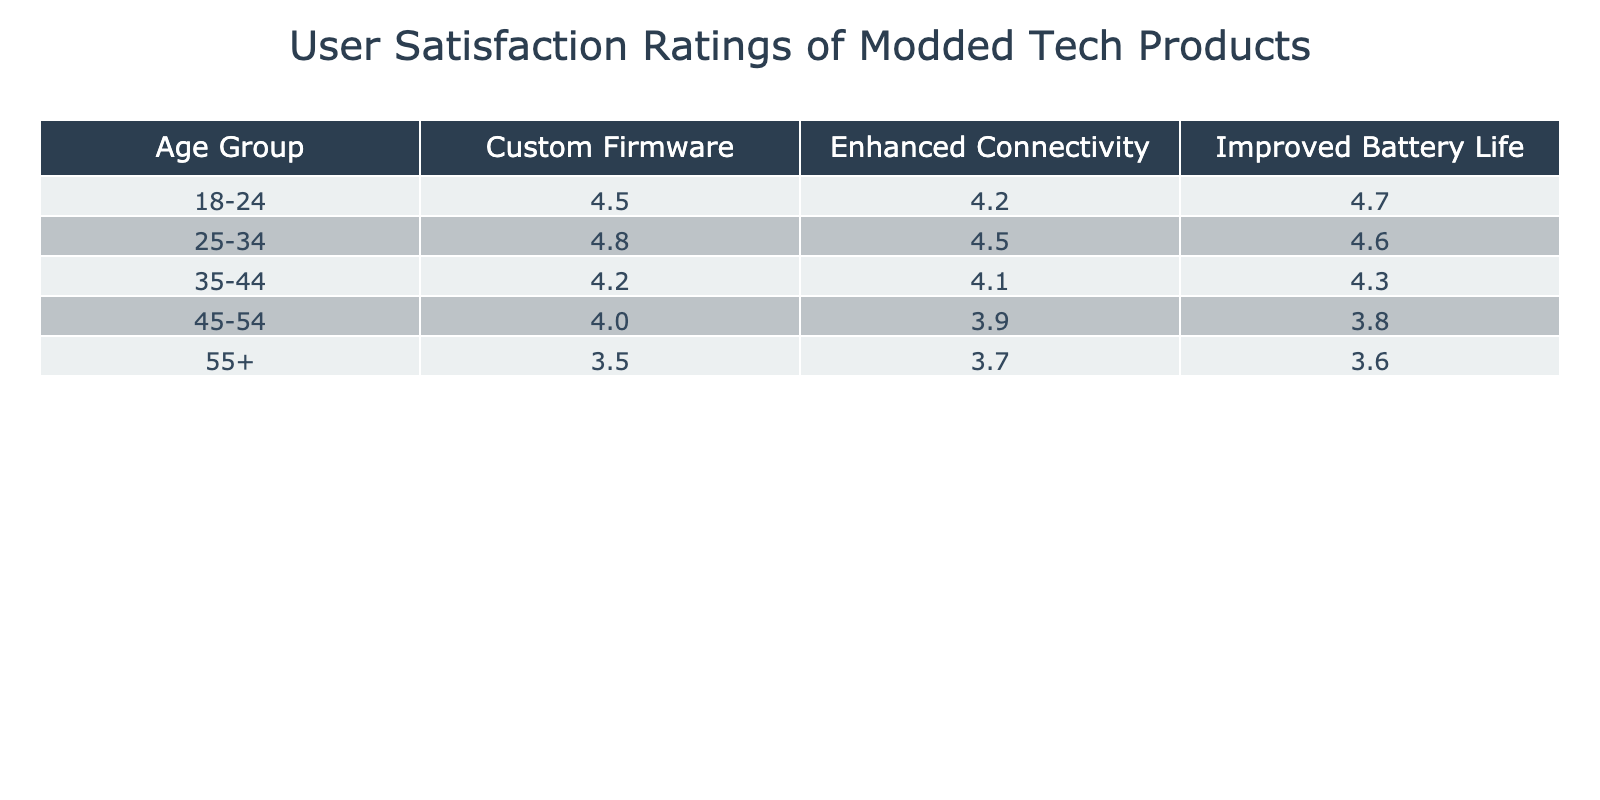What is the satisfaction rating for the Enhanced Connectivity feature among the 25-34 age group? Looking at the row for the 25-34 age group and the Enhanced Connectivity column, the satisfaction rating listed is 4.5.
Answer: 4.5 What is the lowest satisfaction rating for any feature in the 45-54 age group? In the 45-54 age group, the ratings are 4.0 for Custom Firmware, 3.9 for Enhanced Connectivity, and 3.8 for Improved Battery Life. The lowest among these is 3.8.
Answer: 3.8 What is the average satisfaction rating for Custom Firmware across all age groups? The ratings for Custom Firmware are 4.5 (18-24), 4.8 (25-34), 4.2 (35-44), 4.0 (45-54), and 3.5 (55+). Adding these gives 4.5 + 4.8 + 4.2 + 4.0 + 3.5 = 21.0, and dividing by 5 results in an average of 4.2.
Answer: 4.2 Is there a feature that consistently has the highest rating across all age groups? By examining the table, we can see that Improved Battery Life has ratings of 4.7 (18-24), 4.6 (25-34), 4.3 (35-44), 3.8 (45-54), and 3.6 (55+). This indicates that it has the highest rating in three out of five age groups but lower ratings in older demographics. Thus, there is no single feature that consistently has the highest rating across all age groups.
Answer: No Which feature shows the greatest decline in satisfaction from the youngest to the oldest age group? To assess the decline, we can compare the satisfaction ratings for each feature across the ages. For Improved Battery Life: 4.7 (18-24) to 3.6 (55+), a decline of 1.1. For Enhanced Connectivity: 4.2 (18-24) to 3.7 (55+), a decline of 0.5. For Custom Firmware: 4.5 (18-24) to 3.5 (55+), a decline of 1.0. The feature with the greatest decline is Improved Battery Life with 1.1.
Answer: 1.1 